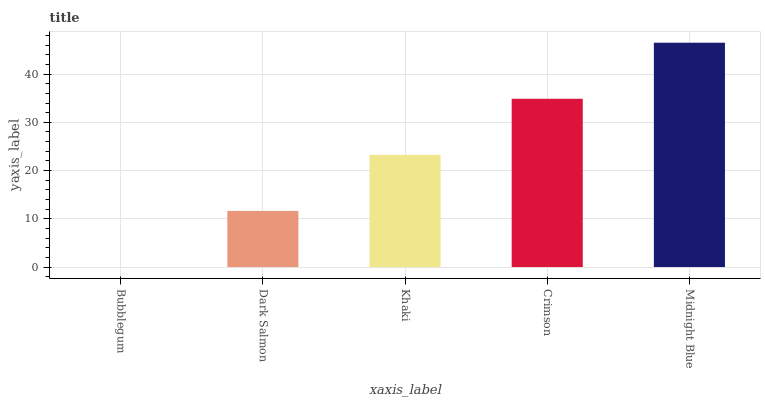Is Bubblegum the minimum?
Answer yes or no. Yes. Is Midnight Blue the maximum?
Answer yes or no. Yes. Is Dark Salmon the minimum?
Answer yes or no. No. Is Dark Salmon the maximum?
Answer yes or no. No. Is Dark Salmon greater than Bubblegum?
Answer yes or no. Yes. Is Bubblegum less than Dark Salmon?
Answer yes or no. Yes. Is Bubblegum greater than Dark Salmon?
Answer yes or no. No. Is Dark Salmon less than Bubblegum?
Answer yes or no. No. Is Khaki the high median?
Answer yes or no. Yes. Is Khaki the low median?
Answer yes or no. Yes. Is Midnight Blue the high median?
Answer yes or no. No. Is Midnight Blue the low median?
Answer yes or no. No. 